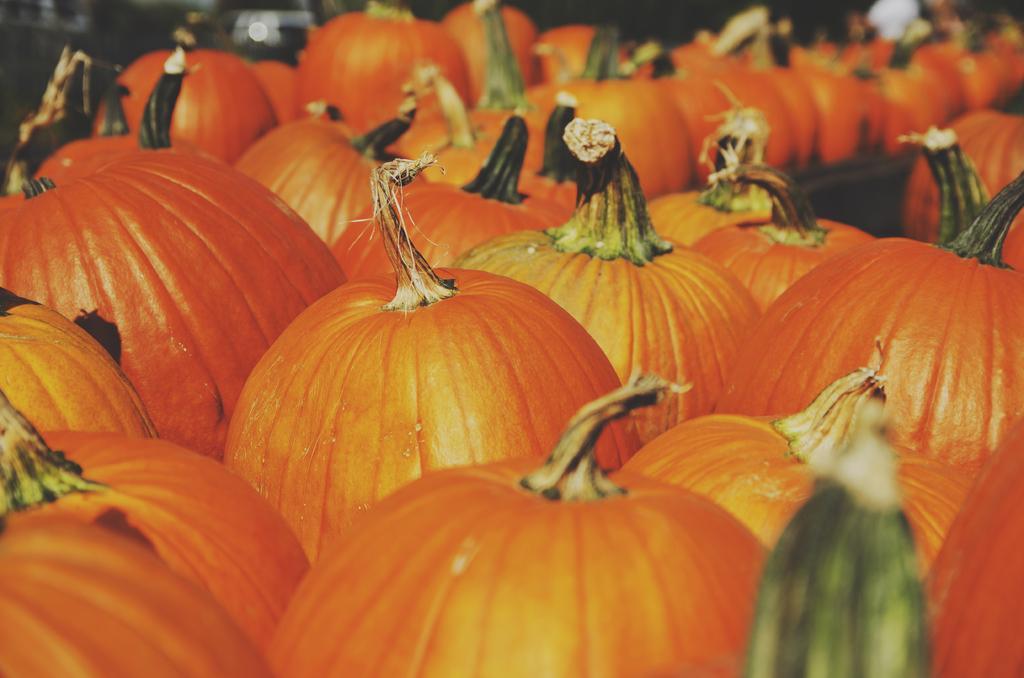How would you summarize this image in a sentence or two? This image consists of pumpkins. They are in orange color. 